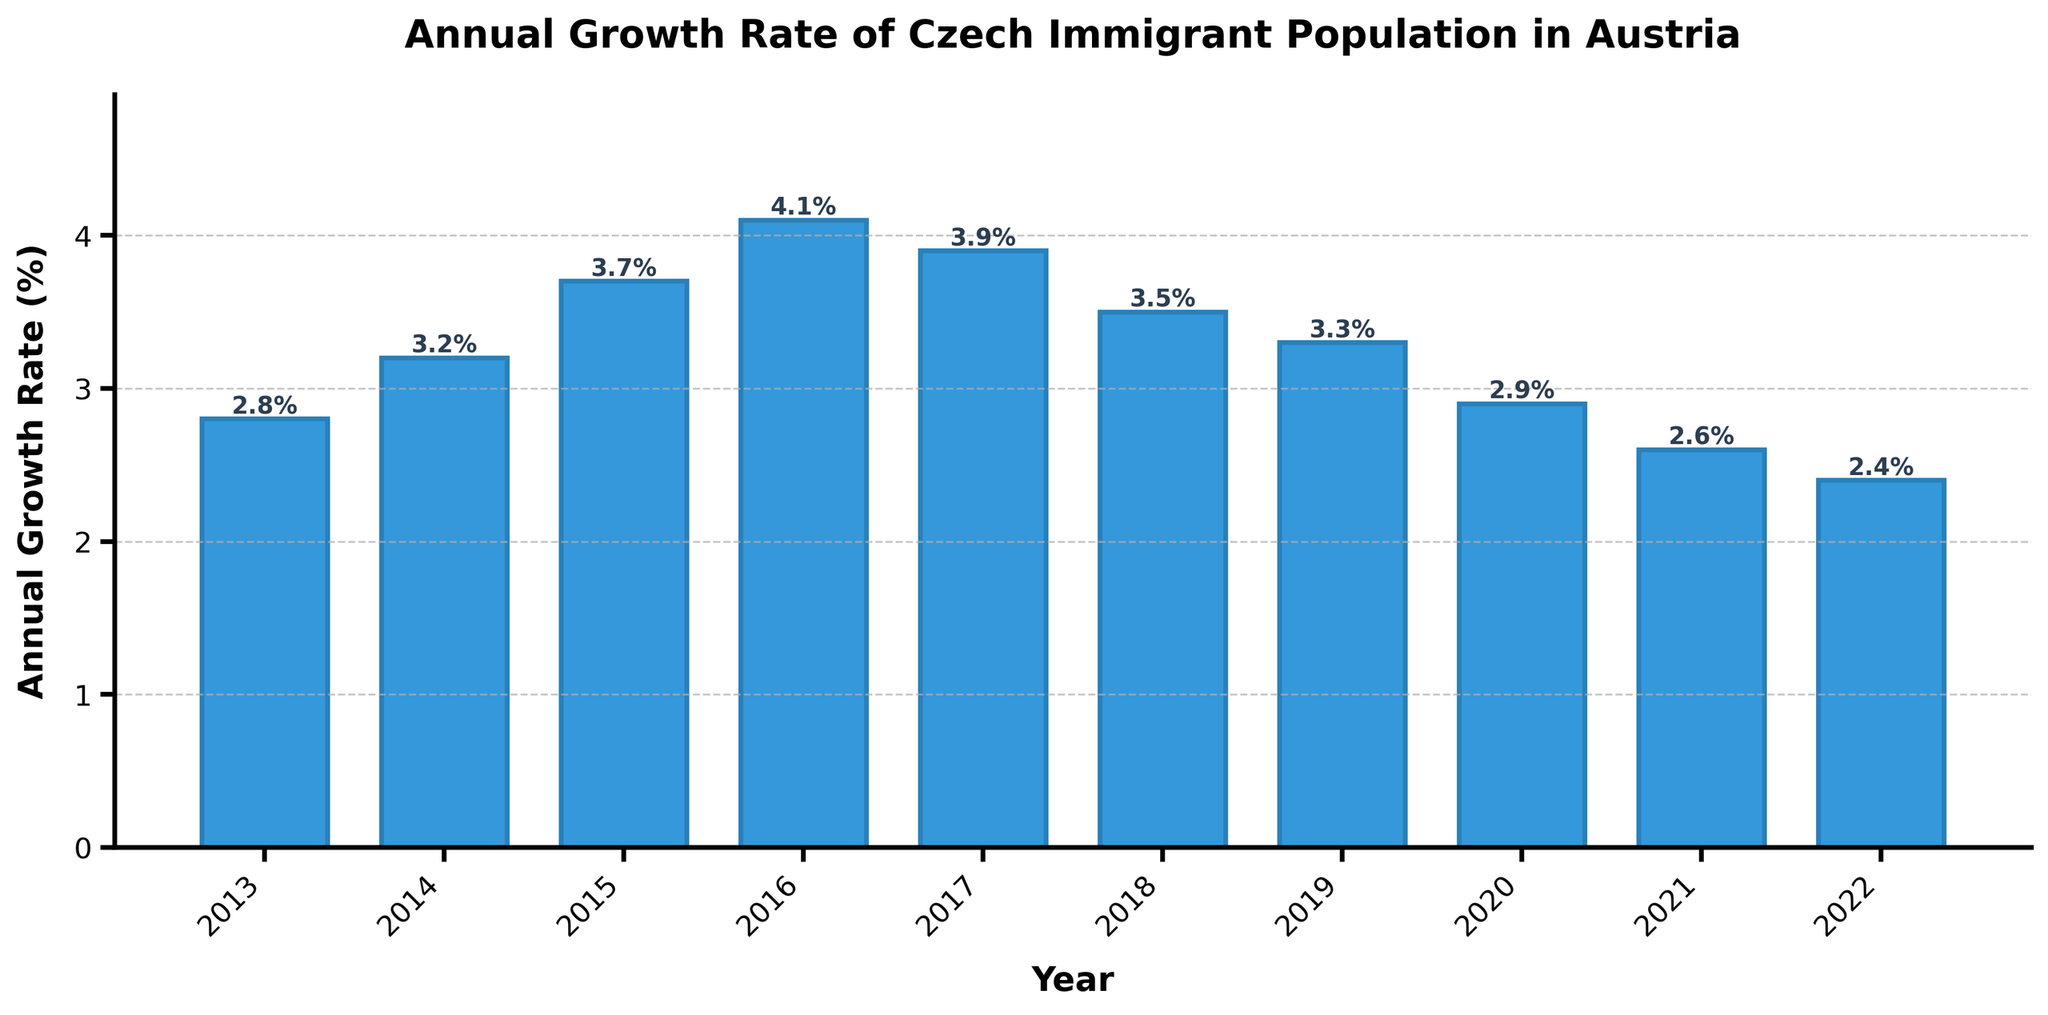What's the highest annual growth rate recorded in the past decade? Refer to the bar heights in the plot. The tallest bar corresponds to the highest annual growth rate, which is 4.1% in 2016.
Answer: 4.1% Which year had the lowest annual growth rate? Look for the shortest bar in the plot. The shortest bar represents the lowest annual growth rate, which is 2.4% in 2022.
Answer: 2022 What is the average annual growth rate over the last decade? Sum the growth rates: 2.8 + 3.2 + 3.7 + 4.1 + 3.9 + 3.5 + 3.3 + 2.9 + 2.6 + 2.4 = 32.4. Divide by the number of years: 32.4 / 10 = 3.24%.
Answer: 3.24% How did the annual growth rate change between 2016 and 2017? Compare the heights of the bars for 2016 (4.1%) and 2017 (3.9%). The growth rate decreased.
Answer: Decreased Which year experienced a higher annual growth rate: 2015 or 2019? Compare the bars for 2015 (3.7%) and 2019 (3.3%). 2015 is higher.
Answer: 2015 By how much did the annual growth rate decline from 2017 to 2022? Subtract the 2022 rate (2.4%) from the 2017 rate (3.9%): 3.9 - 2.4 = 1.5%.
Answer: 1.5% Identify the three consecutive years with the highest average annual growth rate. Calculate averages for each three-year span: 
2013-2015: (2.8+3.2+3.7)/3 = 3.23
2014-2016: (3.2+3.7+4.1)/3 = 3.67
2015-2017: (3.7+4.1+3.9)/3 = 3.90
2016-2018: (4.1+3.9+3.5)/3 = 3.83
2017-2019: (3.9+3.5+3.3)/3 = 3.57
2018-2020: (3.5+3.3+2.9)/3 = 3.23
2019-2021: (3.3+2.9+2.6)/3 = 2.93
2020-2022: (2.9+2.6+2.4)/3 = 2.63
The highest average is 3.90 for 2015-2017.
Answer: 2015-2017 Compare the growth rate in 2020 with that in 2014. Which had a higher growth rate, and by how much? 2020 (2.9%) and 2014 (3.2%). 2014 is higher. Difference: 3.2 - 2.9 = 0.3%.
Answer: 2014 by 0.3% Which years had a growth rate of at least 3.5%? Identify bars that are 3.5% or higher: 2014 (3.2%), 2015 (3.7%), 2016 (4.1%), 2017 (3.9%), 2018 (3.5%). Exclude 2014 as it is below 3.5%.
Answer: 2015, 2016, 2017, 2018 